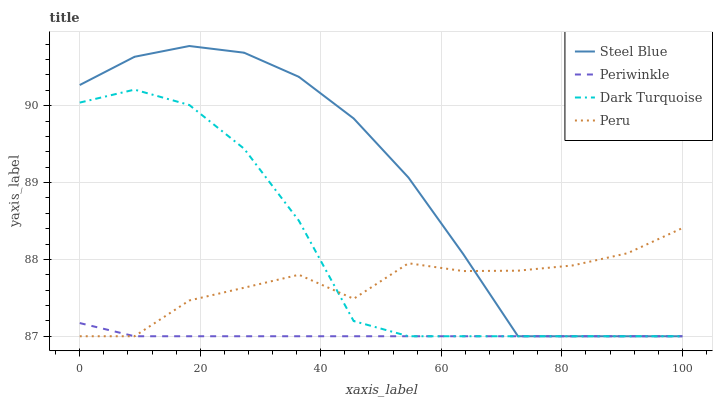Does Periwinkle have the minimum area under the curve?
Answer yes or no. Yes. Does Steel Blue have the maximum area under the curve?
Answer yes or no. Yes. Does Steel Blue have the minimum area under the curve?
Answer yes or no. No. Does Periwinkle have the maximum area under the curve?
Answer yes or no. No. Is Periwinkle the smoothest?
Answer yes or no. Yes. Is Peru the roughest?
Answer yes or no. Yes. Is Steel Blue the smoothest?
Answer yes or no. No. Is Steel Blue the roughest?
Answer yes or no. No. Does Dark Turquoise have the lowest value?
Answer yes or no. Yes. Does Steel Blue have the highest value?
Answer yes or no. Yes. Does Periwinkle have the highest value?
Answer yes or no. No. Does Dark Turquoise intersect Periwinkle?
Answer yes or no. Yes. Is Dark Turquoise less than Periwinkle?
Answer yes or no. No. Is Dark Turquoise greater than Periwinkle?
Answer yes or no. No. 